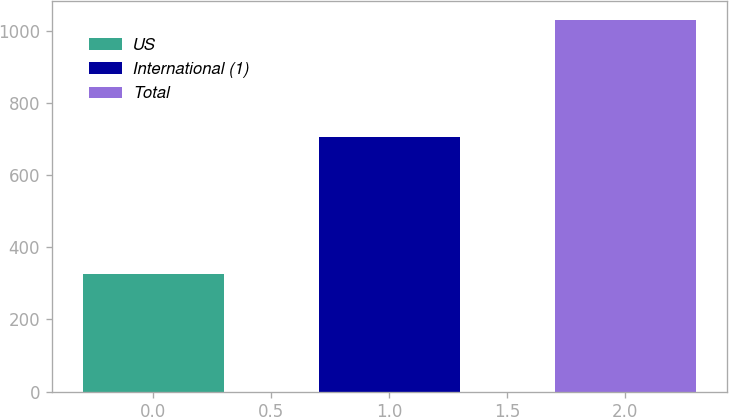Convert chart to OTSL. <chart><loc_0><loc_0><loc_500><loc_500><bar_chart><fcel>US<fcel>International (1)<fcel>Total<nl><fcel>326<fcel>704<fcel>1030<nl></chart> 